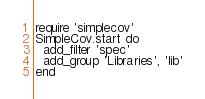<code> <loc_0><loc_0><loc_500><loc_500><_Ruby_>require 'simplecov'
SimpleCov.start do
  add_filter 'spec'
  add_group 'Libraries', 'lib'
end</code> 